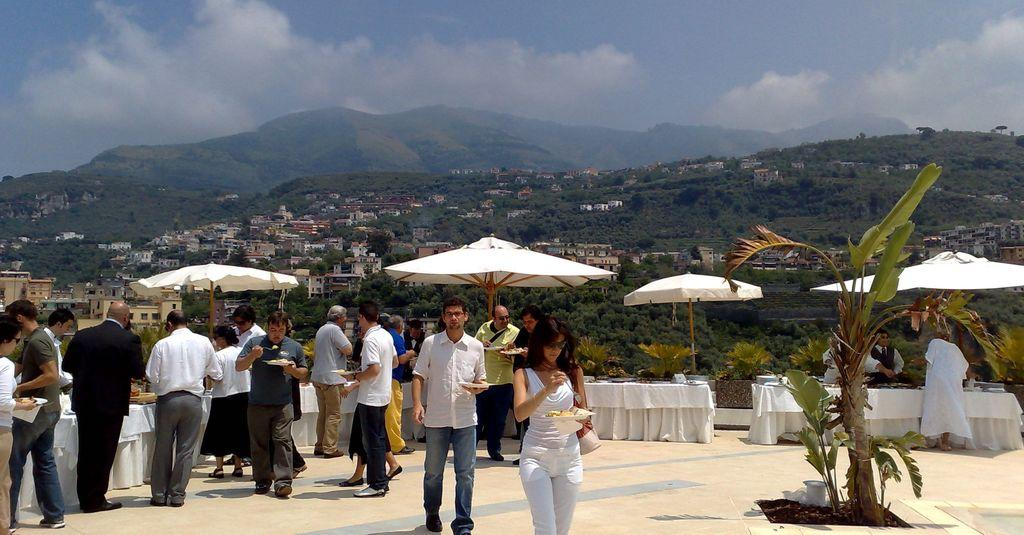What is happening with the group of people in the image? The people in the image are eating. What is covering the food counters in the image? There are tents above the food counters in the image. What can be seen in the distance in the image? Mountains and houses are visible in the background of the image. How many toothbrushes can be seen in the image? There are no toothbrushes present in the image. What type of birds are flying over the mountains in the image? There are no birds visible in the image; only mountains and houses can be seen in the background. 